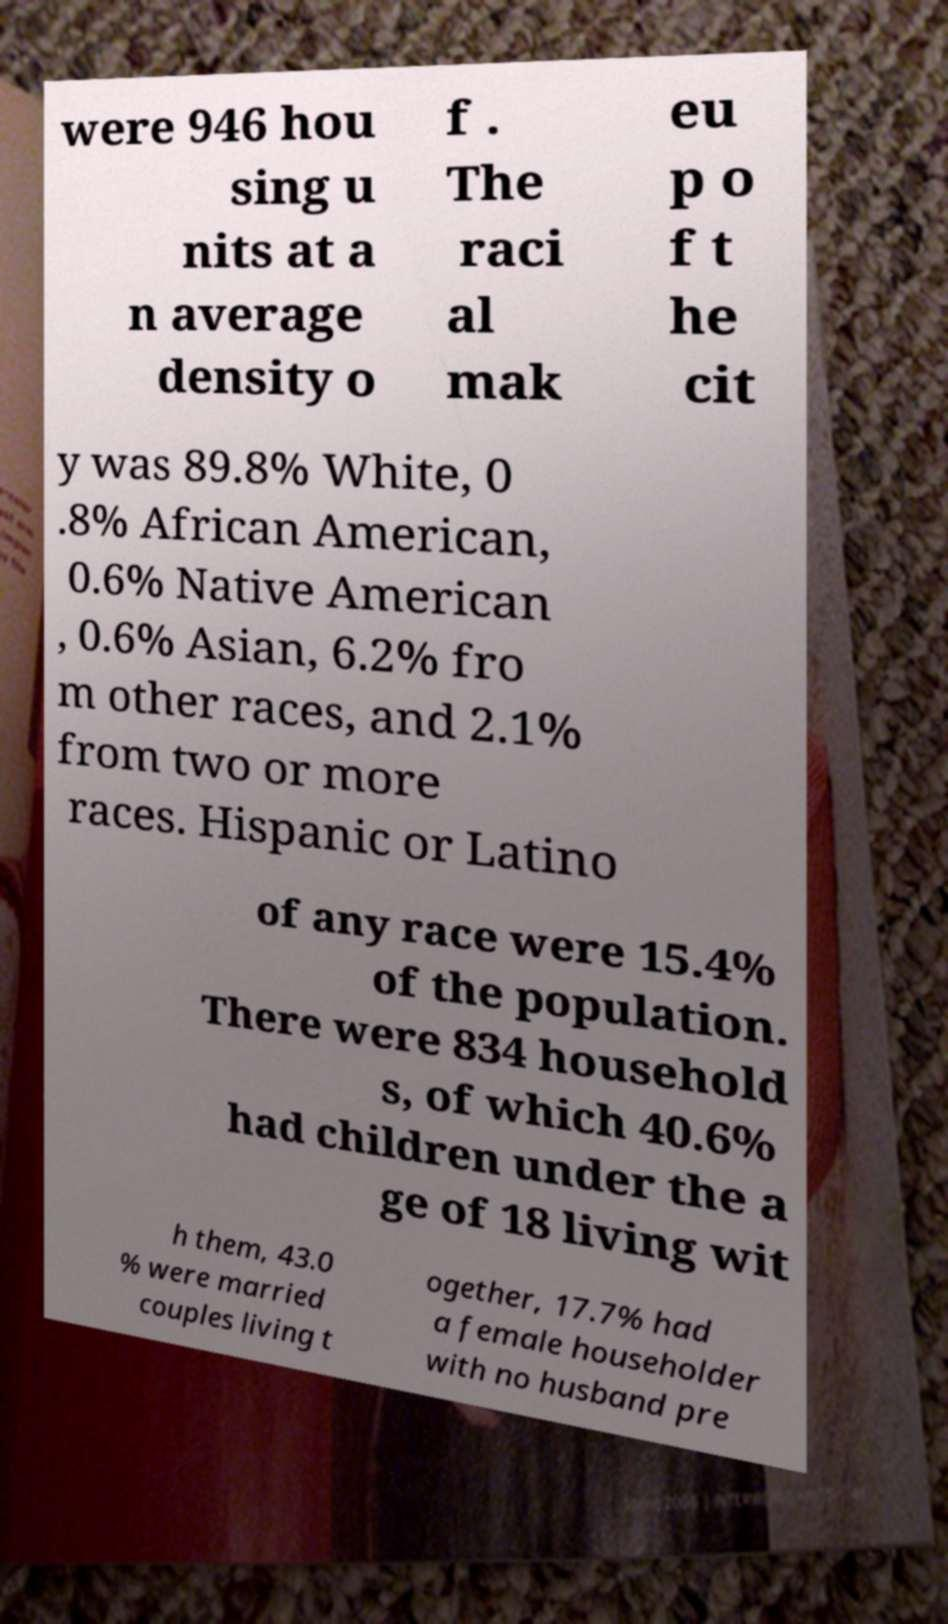Could you assist in decoding the text presented in this image and type it out clearly? were 946 hou sing u nits at a n average density o f . The raci al mak eu p o f t he cit y was 89.8% White, 0 .8% African American, 0.6% Native American , 0.6% Asian, 6.2% fro m other races, and 2.1% from two or more races. Hispanic or Latino of any race were 15.4% of the population. There were 834 household s, of which 40.6% had children under the a ge of 18 living wit h them, 43.0 % were married couples living t ogether, 17.7% had a female householder with no husband pre 